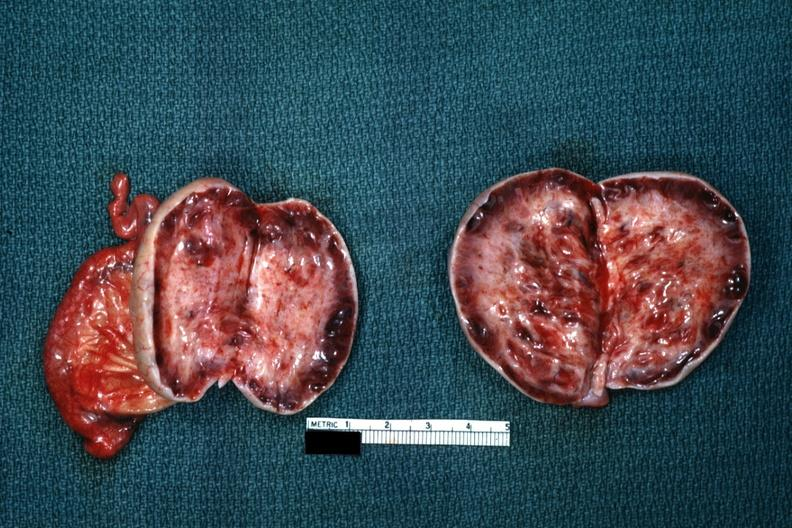s stein leventhal present?
Answer the question using a single word or phrase. Yes 